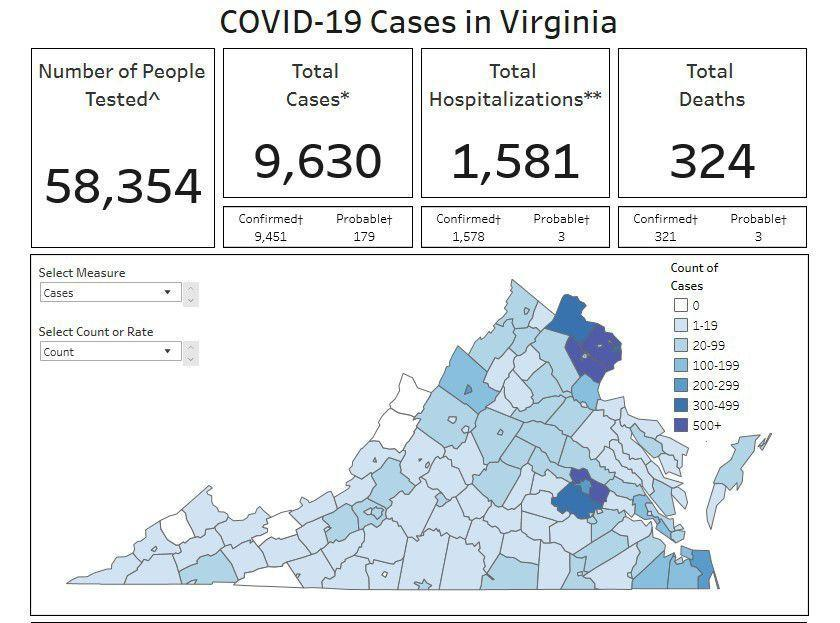What is the probable number of covid positive cases in Virginia?
Answer the question with a short phrase. 179 How many confirmed covid positive cases were hospitalized in Virginia? 1,578 How many people were tested for COVID-19 in Virginia? 58,354 What is the number of probable COVID-19 deaths in Virginia? 3 What is the number of confirmed covid positive cases in Virginia? 9,451 What is the total number of COVID-19 deaths in Virginia? 324 What is the total number of COVID-19 cases reported in Virginia? 9,630 